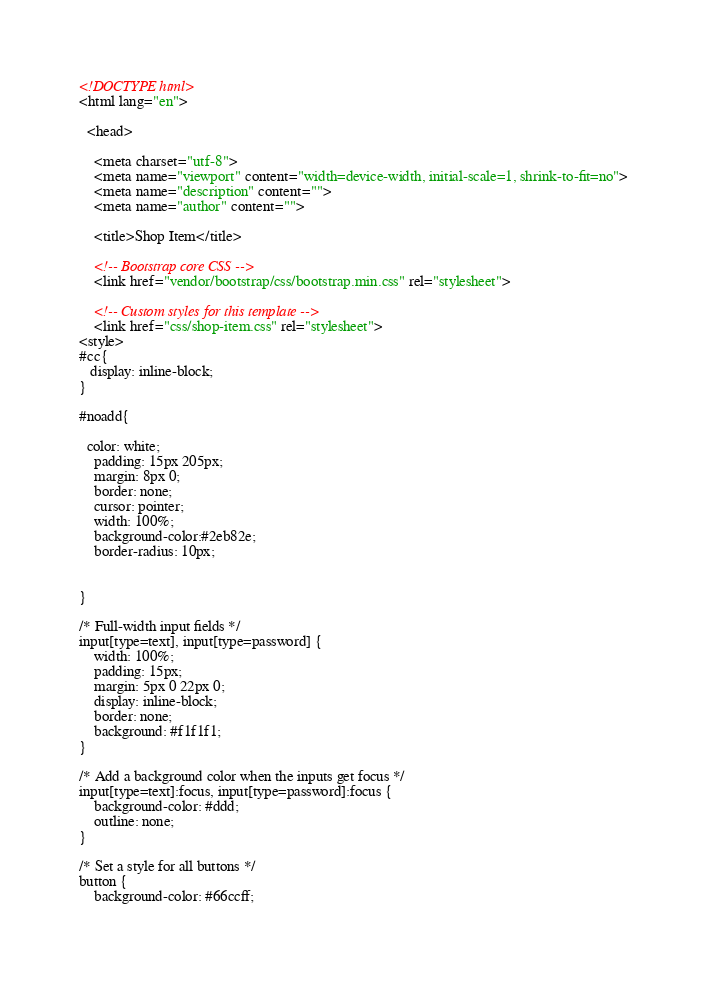Convert code to text. <code><loc_0><loc_0><loc_500><loc_500><_HTML_><!DOCTYPE html>
<html lang="en">

  <head>

    <meta charset="utf-8">
    <meta name="viewport" content="width=device-width, initial-scale=1, shrink-to-fit=no">
    <meta name="description" content="">
    <meta name="author" content="">

    <title>Shop Item</title>

    <!-- Bootstrap core CSS -->
    <link href="vendor/bootstrap/css/bootstrap.min.css" rel="stylesheet">

    <!-- Custom styles for this template -->
    <link href="css/shop-item.css" rel="stylesheet">
<style>
#cc{
   display: inline-block;
}

#noadd{

  color: white;
    padding: 15px 205px;
    margin: 8px 0;
    border: none;
    cursor: pointer;
    width: 100%;
    background-color:#2eb82e;
    border-radius: 10px;


}

/* Full-width input fields */
input[type=text], input[type=password] {
    width: 100%;
    padding: 15px;
    margin: 5px 0 22px 0;
    display: inline-block;
    border: none;
    background: #f1f1f1;
}

/* Add a background color when the inputs get focus */
input[type=text]:focus, input[type=password]:focus {
    background-color: #ddd;
    outline: none;
}

/* Set a style for all buttons */
button {
    background-color: #66ccff;</code> 